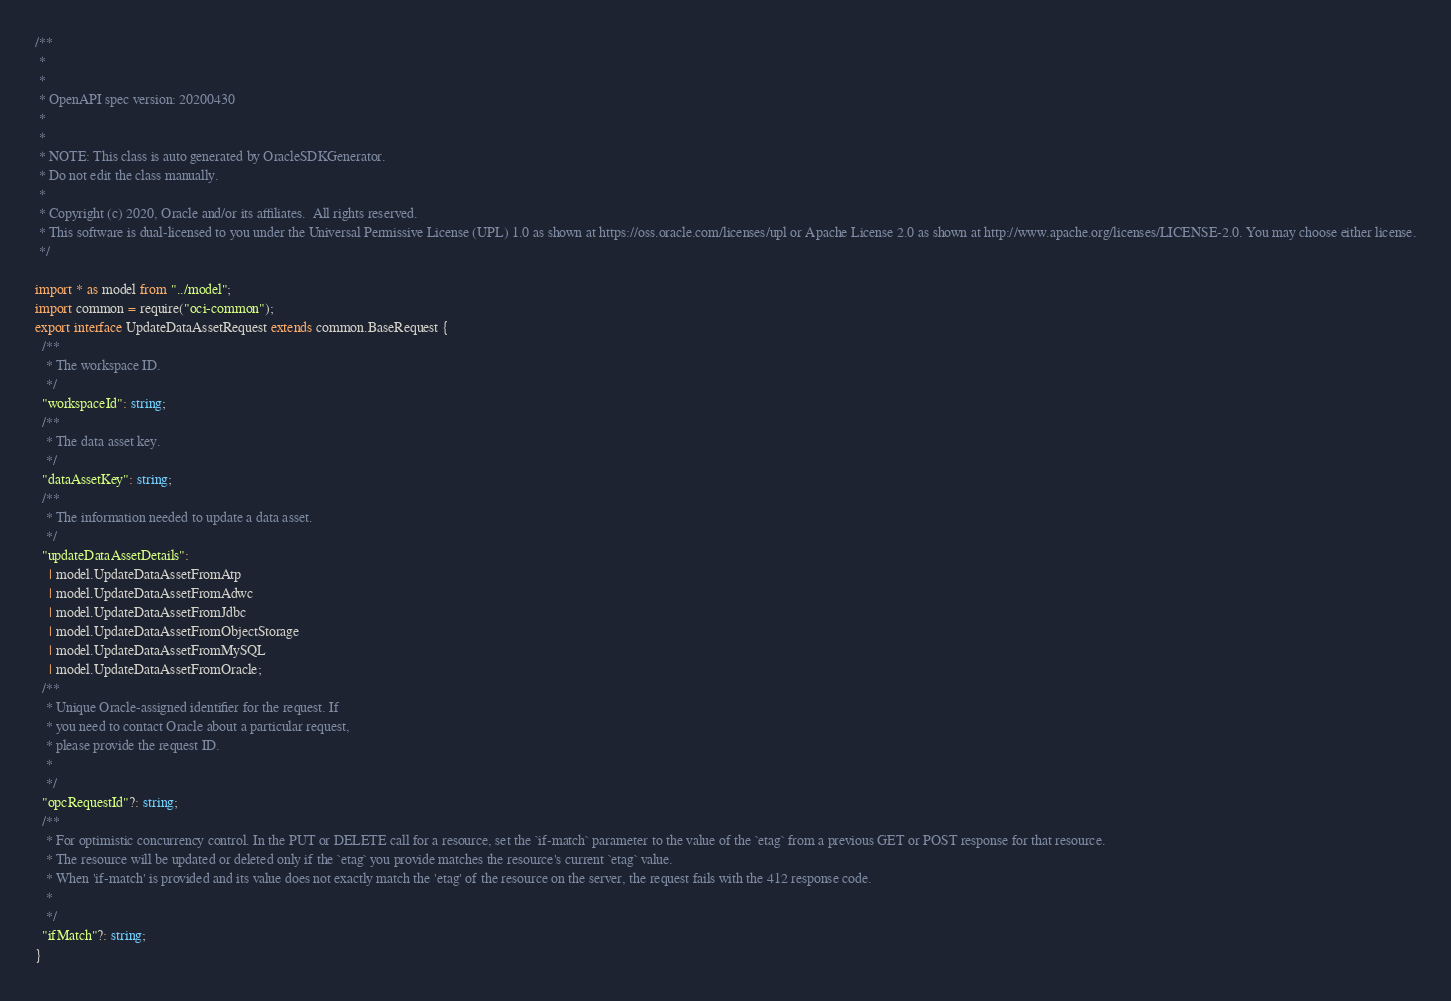<code> <loc_0><loc_0><loc_500><loc_500><_TypeScript_>/**
 *
 *
 * OpenAPI spec version: 20200430
 *
 *
 * NOTE: This class is auto generated by OracleSDKGenerator.
 * Do not edit the class manually.
 *
 * Copyright (c) 2020, Oracle and/or its affiliates.  All rights reserved.
 * This software is dual-licensed to you under the Universal Permissive License (UPL) 1.0 as shown at https://oss.oracle.com/licenses/upl or Apache License 2.0 as shown at http://www.apache.org/licenses/LICENSE-2.0. You may choose either license.
 */

import * as model from "../model";
import common = require("oci-common");
export interface UpdateDataAssetRequest extends common.BaseRequest {
  /**
   * The workspace ID.
   */
  "workspaceId": string;
  /**
   * The data asset key.
   */
  "dataAssetKey": string;
  /**
   * The information needed to update a data asset.
   */
  "updateDataAssetDetails":
    | model.UpdateDataAssetFromAtp
    | model.UpdateDataAssetFromAdwc
    | model.UpdateDataAssetFromJdbc
    | model.UpdateDataAssetFromObjectStorage
    | model.UpdateDataAssetFromMySQL
    | model.UpdateDataAssetFromOracle;
  /**
   * Unique Oracle-assigned identifier for the request. If
   * you need to contact Oracle about a particular request,
   * please provide the request ID.
   *
   */
  "opcRequestId"?: string;
  /**
   * For optimistic concurrency control. In the PUT or DELETE call for a resource, set the `if-match` parameter to the value of the `etag` from a previous GET or POST response for that resource.
   * The resource will be updated or deleted only if the `etag` you provide matches the resource's current `etag` value.
   * When 'if-match' is provided and its value does not exactly match the 'etag' of the resource on the server, the request fails with the 412 response code.
   *
   */
  "ifMatch"?: string;
}
</code> 